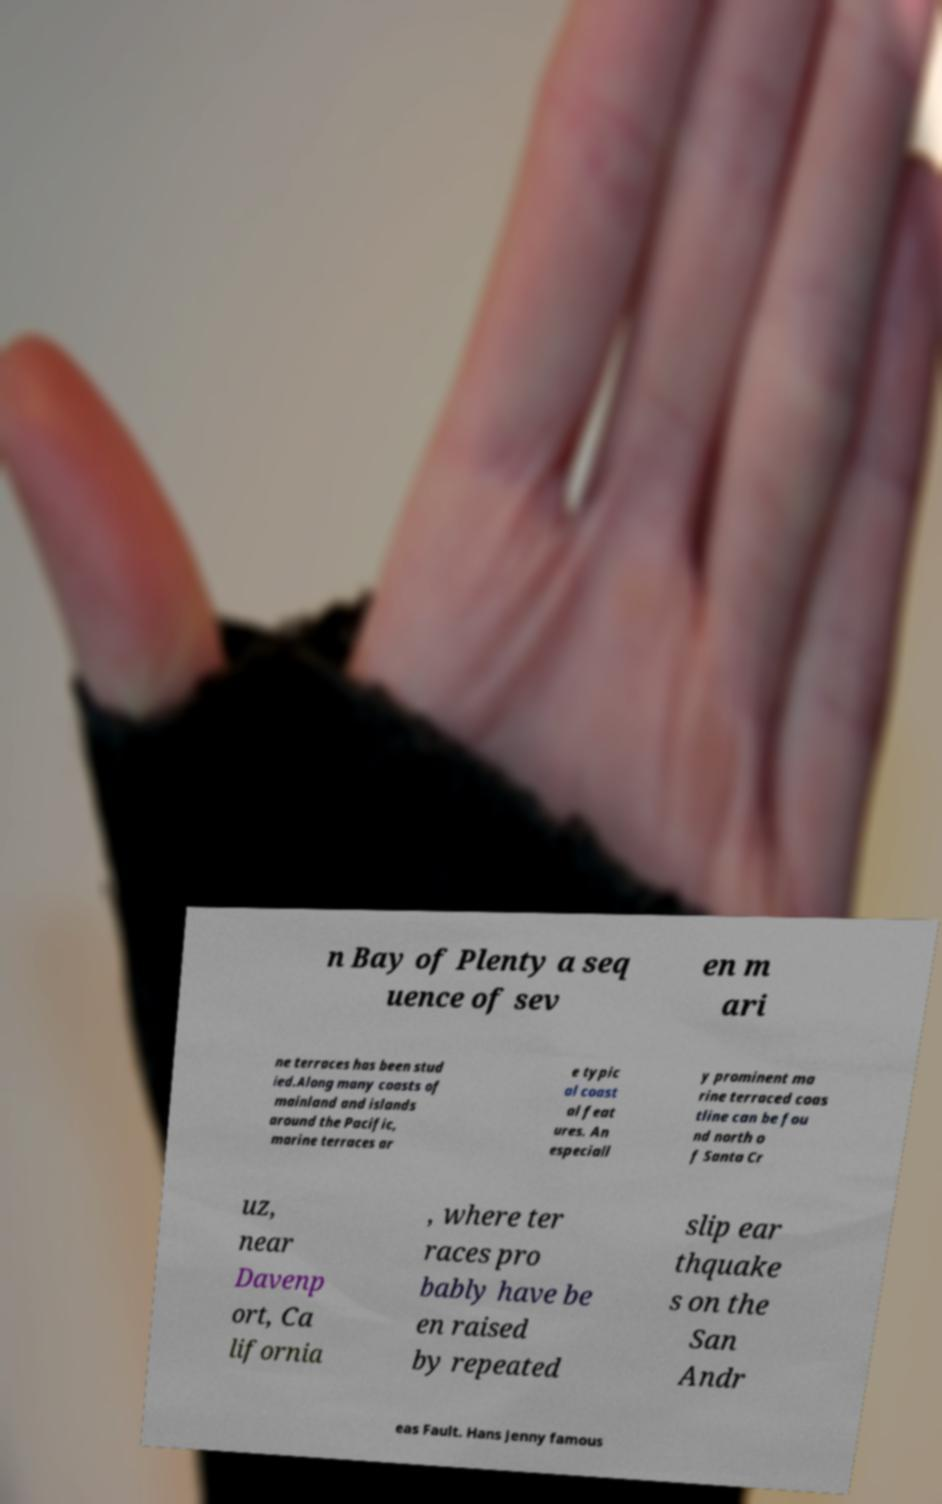Please read and relay the text visible in this image. What does it say? n Bay of Plenty a seq uence of sev en m ari ne terraces has been stud ied.Along many coasts of mainland and islands around the Pacific, marine terraces ar e typic al coast al feat ures. An especiall y prominent ma rine terraced coas tline can be fou nd north o f Santa Cr uz, near Davenp ort, Ca lifornia , where ter races pro bably have be en raised by repeated slip ear thquake s on the San Andr eas Fault. Hans Jenny famous 